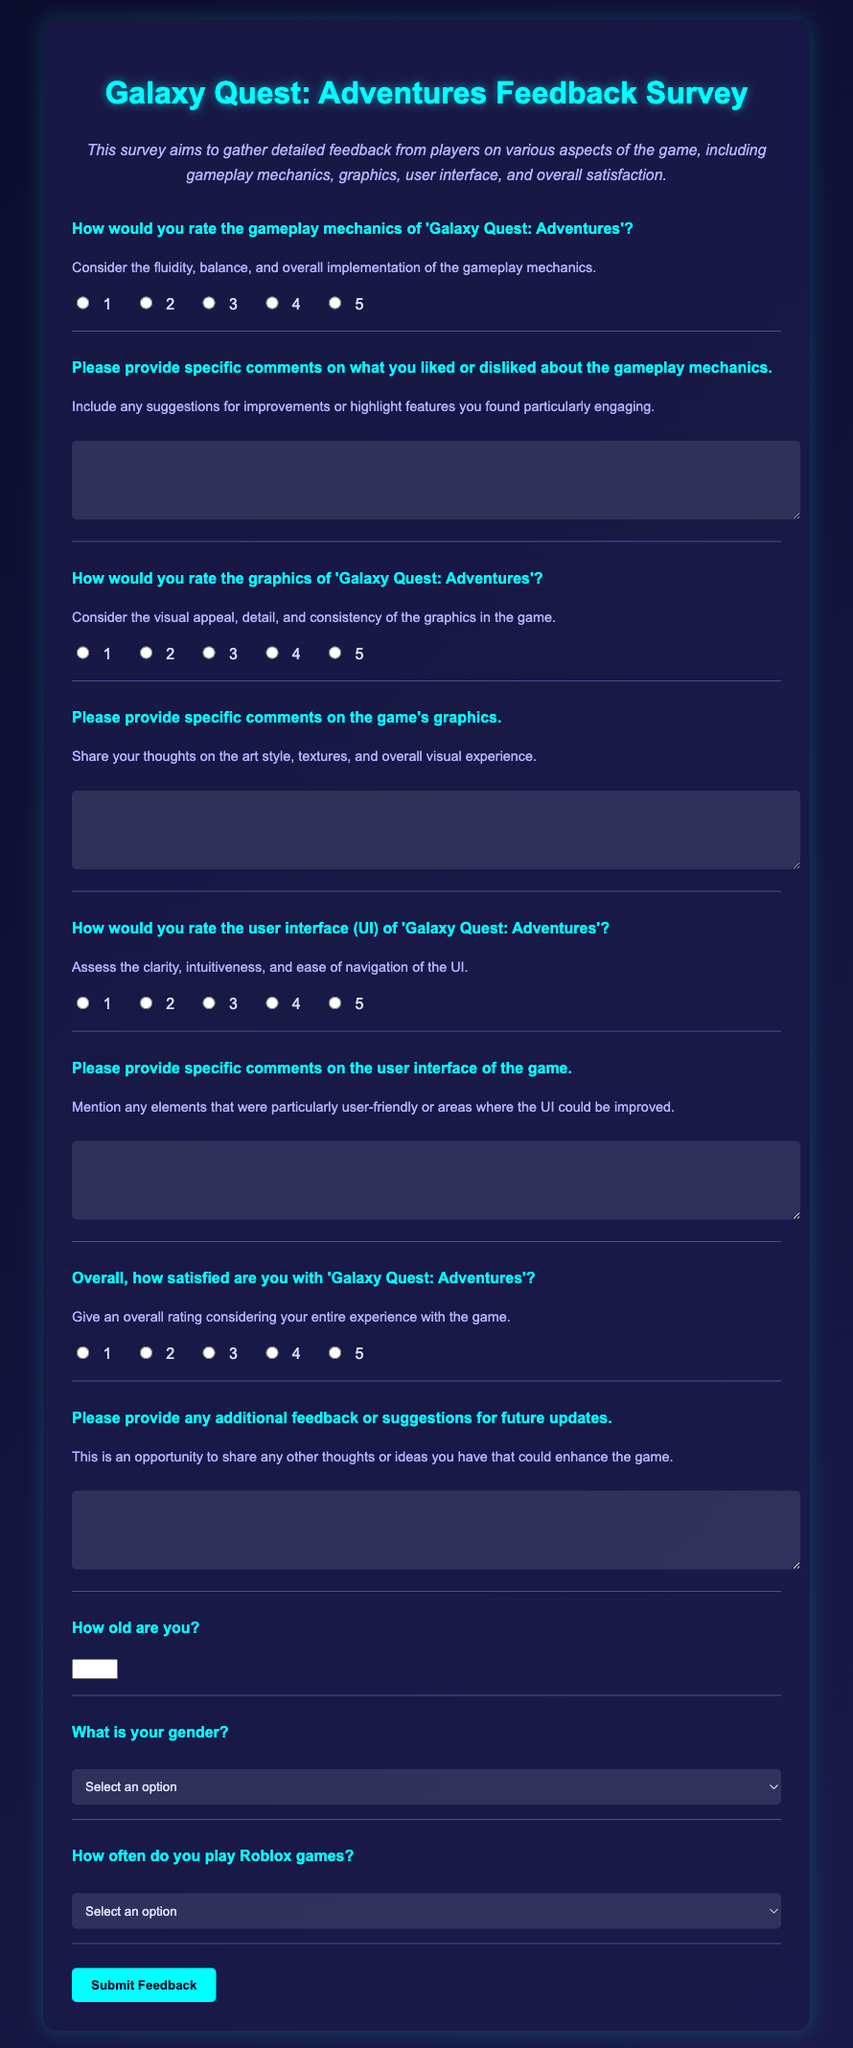How would you rate the gameplay mechanics of 'Galaxy Quest: Adventures'? This question asks for a numerical rating based on players' opinions about gameplay mechanics, indicated by radio buttons from 1 to 5.
Answer: 1-5 What is the title of the survey? The title of the survey appears at the top of the document and specifies which game it relates to.
Answer: Galaxy Quest: Adventures Feedback Survey How often do you play Roblox games? This question allows respondents to select their frequency of playing Roblox games from a dropdown list.
Answer: Daily, several times a week, once a week, several times a month, or rarely What is one of the aspects players are asked to comment on in their feedback? This question refers to specific areas where player feedback is solicited, which are listed in the survey.
Answer: Gameplay mechanics, graphics, user interface, or overall satisfaction What option is available for respondents who do not want to disclose their gender? This part of the survey includes a specific option for respondents who prefer not to share their gender.
Answer: Prefer not to say How old can a survey respondent be at minimum? This question examines the age restriction set for respondents in the survey.
Answer: 1 Please provide any additional feedback or suggestions for future updates. This open-ended question invites players to share their thoughts beyond specific ratings.
Answer: Open-ended response 